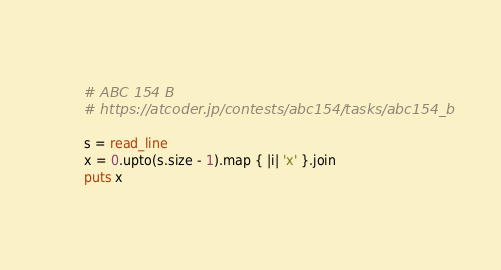Convert code to text. <code><loc_0><loc_0><loc_500><loc_500><_Crystal_># ABC 154 B
# https://atcoder.jp/contests/abc154/tasks/abc154_b

s = read_line
x = 0.upto(s.size - 1).map { |i| 'x' }.join
puts x
</code> 